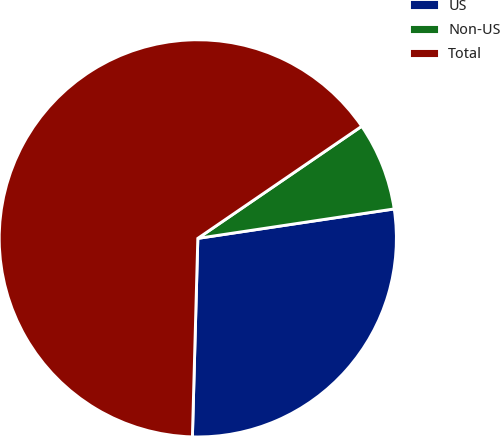Convert chart. <chart><loc_0><loc_0><loc_500><loc_500><pie_chart><fcel>US<fcel>Non-US<fcel>Total<nl><fcel>27.8%<fcel>7.18%<fcel>65.01%<nl></chart> 